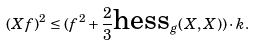Convert formula to latex. <formula><loc_0><loc_0><loc_500><loc_500>( X f ) ^ { 2 } \leq ( f ^ { 2 } + \frac { 2 } { 3 } \text {hess} _ { g } ( X , X ) ) \cdot k .</formula> 